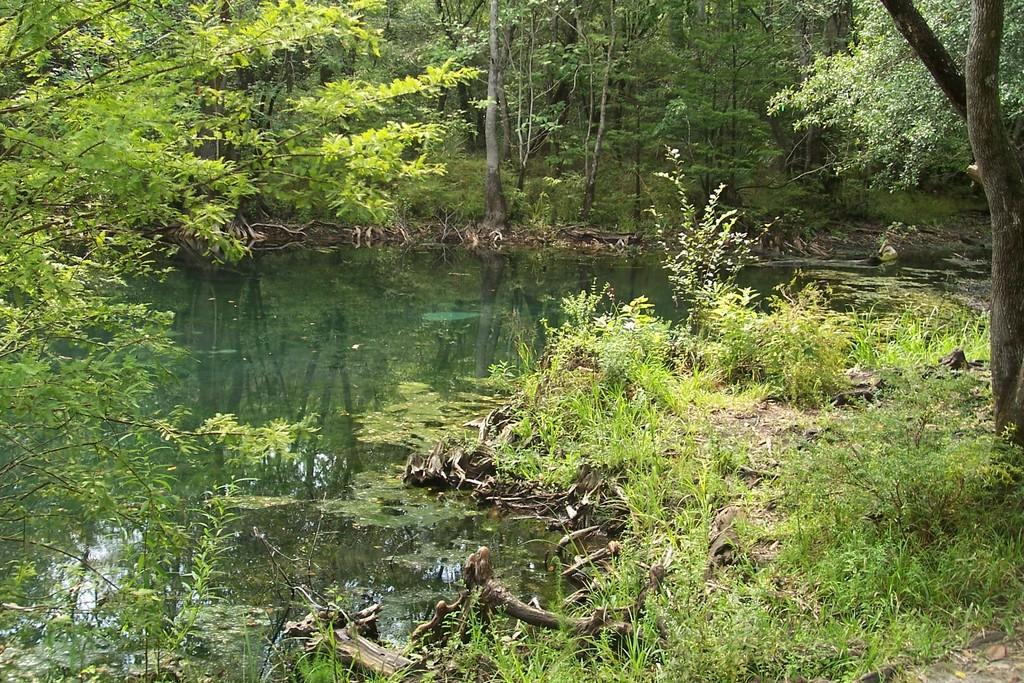What is the main feature in the picture? There is a pond in the picture. What can be found inside the pond? There are twigs and leaves in the pond. What is visible in the backdrop of the picture? There is grass, plants, and trees in the backdrop of the picture. What advertisement can be seen in the space above the pond? There is no advertisement or space above the pond in the image; it only features a pond with twigs and leaves, and a backdrop of grass, plants, and trees. 